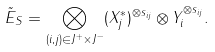<formula> <loc_0><loc_0><loc_500><loc_500>\tilde { E } _ { S } = \bigotimes _ { ( i , j ) \in J ^ { + } \times J ^ { - } } ( X _ { j } ^ { * } ) ^ { \otimes s _ { i j } } \otimes Y _ { i } ^ { \otimes s _ { i j } } .</formula> 